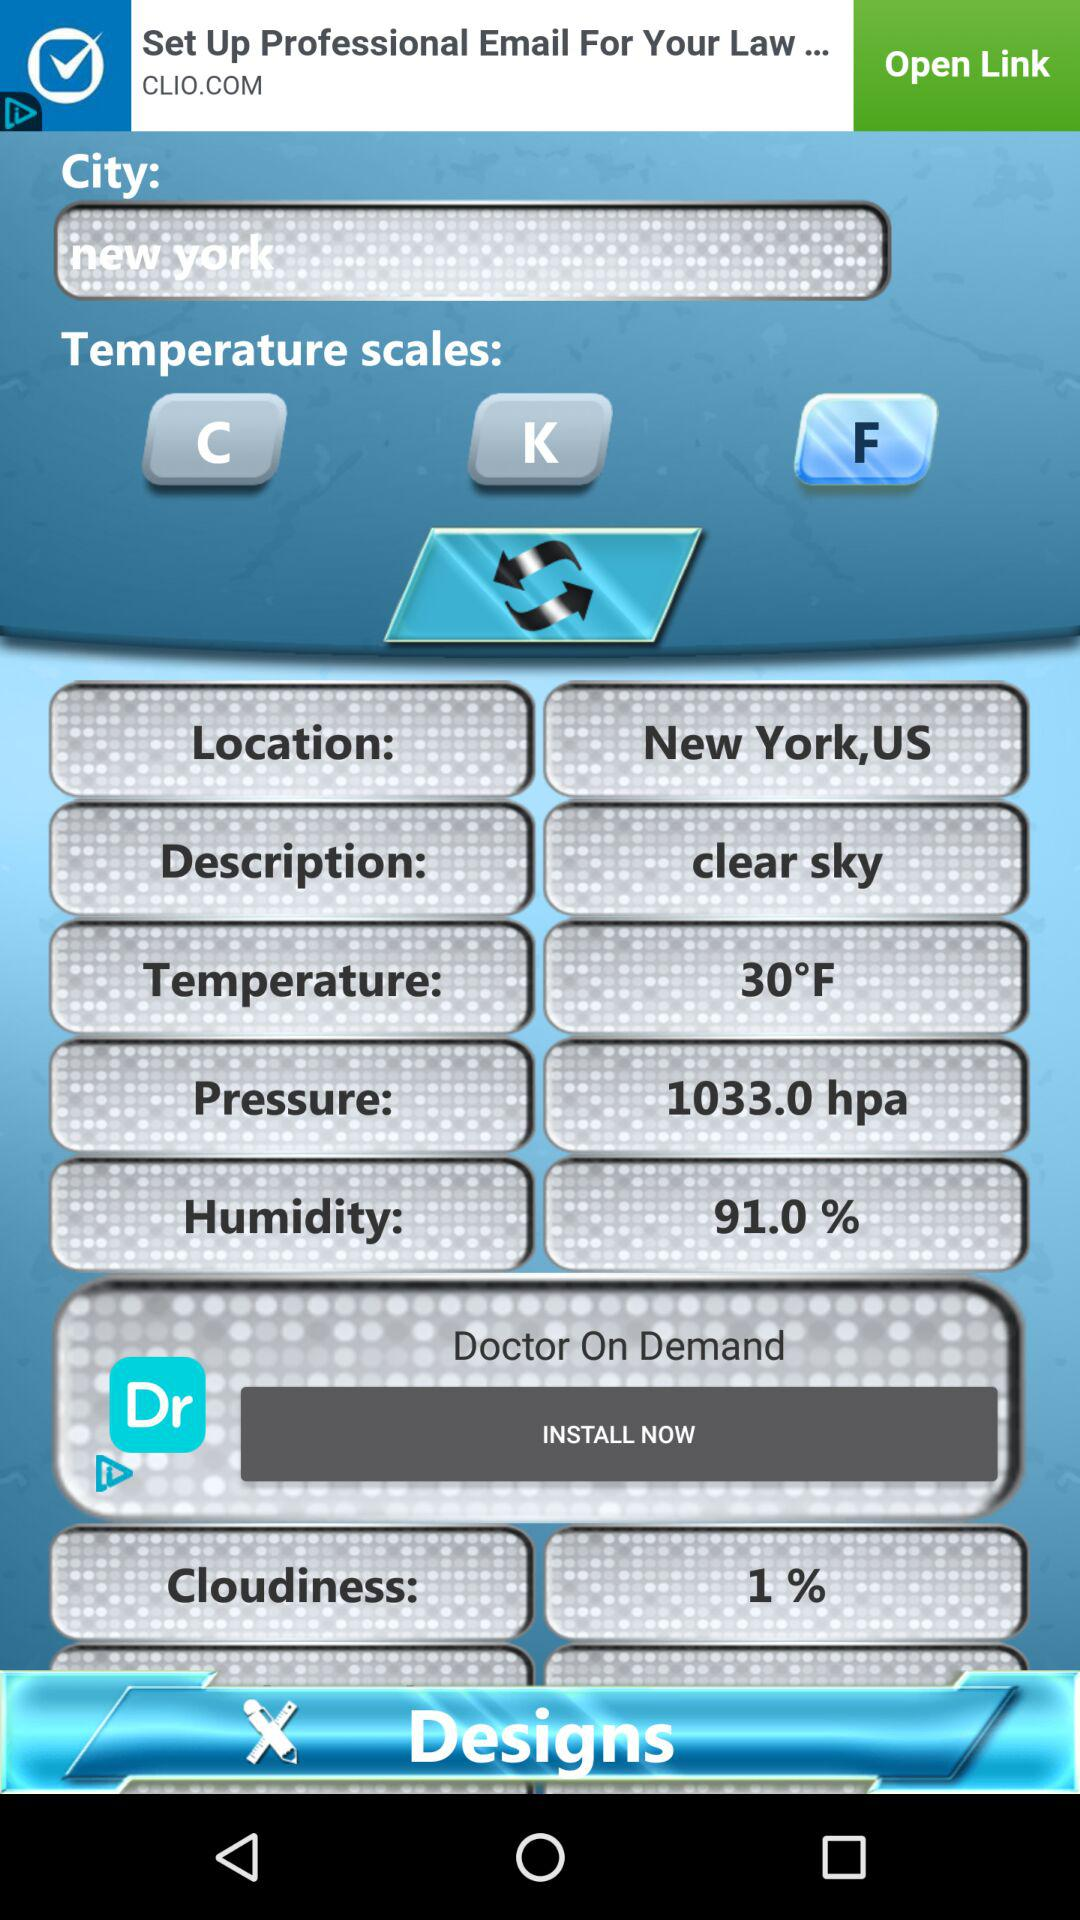What is the version of this application?
When the provided information is insufficient, respond with <no answer>. <no answer> 